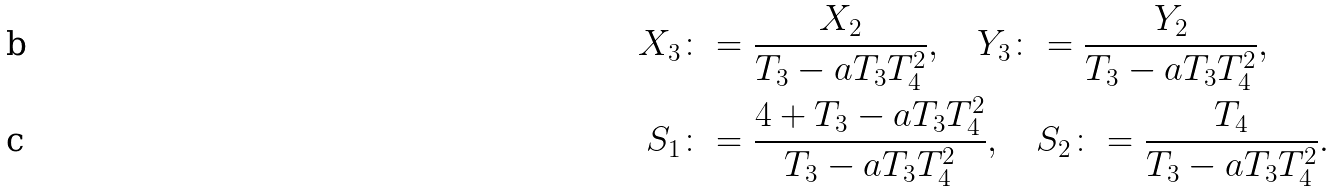<formula> <loc_0><loc_0><loc_500><loc_500>X _ { 3 } & \colon = \frac { X _ { 2 } } { T _ { 3 } - a T _ { 3 } T _ { 4 } ^ { 2 } } , \quad Y _ { 3 } \colon = \frac { Y _ { 2 } } { T _ { 3 } - a T _ { 3 } T _ { 4 } ^ { 2 } } , \\ S _ { 1 } & \colon = \frac { 4 + T _ { 3 } - a T _ { 3 } T _ { 4 } ^ { 2 } } { T _ { 3 } - a T _ { 3 } T _ { 4 } ^ { 2 } } , \quad S _ { 2 } \colon = \frac { T _ { 4 } } { T _ { 3 } - a T _ { 3 } T _ { 4 } ^ { 2 } } .</formula> 